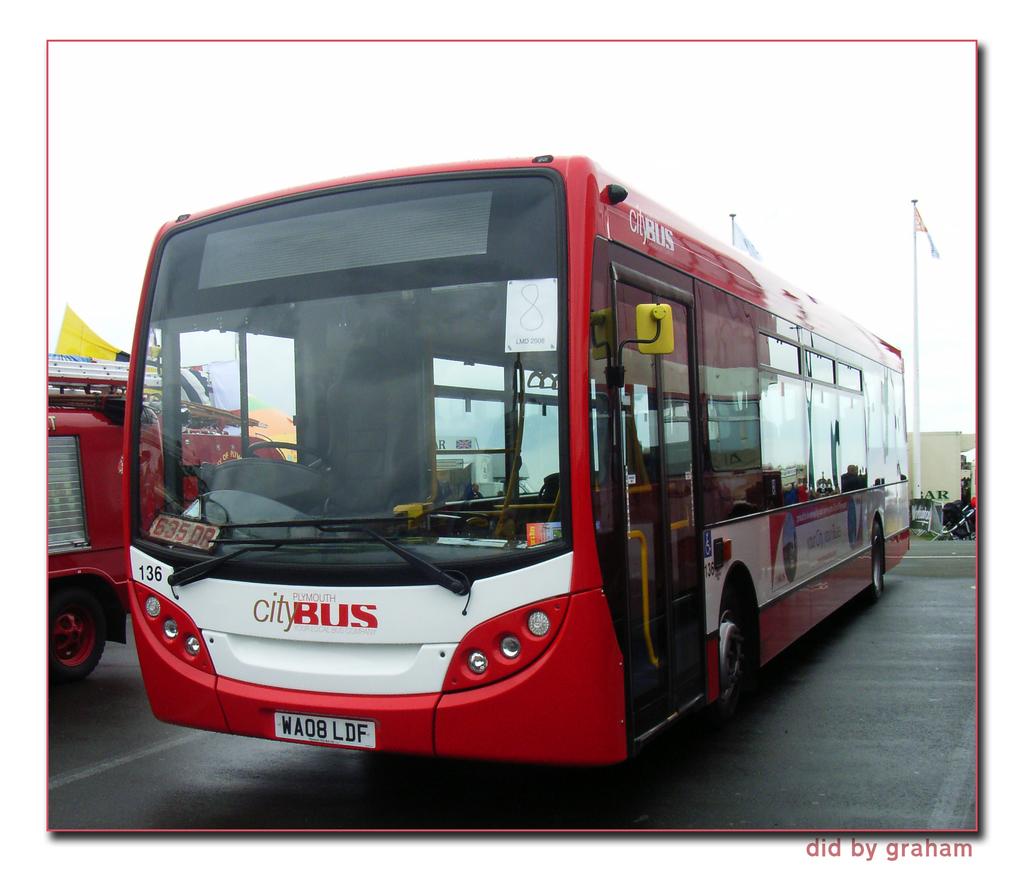What is the license plate for this bus?
Your answer should be very brief. Wa08 ldf. What is written on the front of the bus, above the license plate?
Offer a terse response. City bus. 